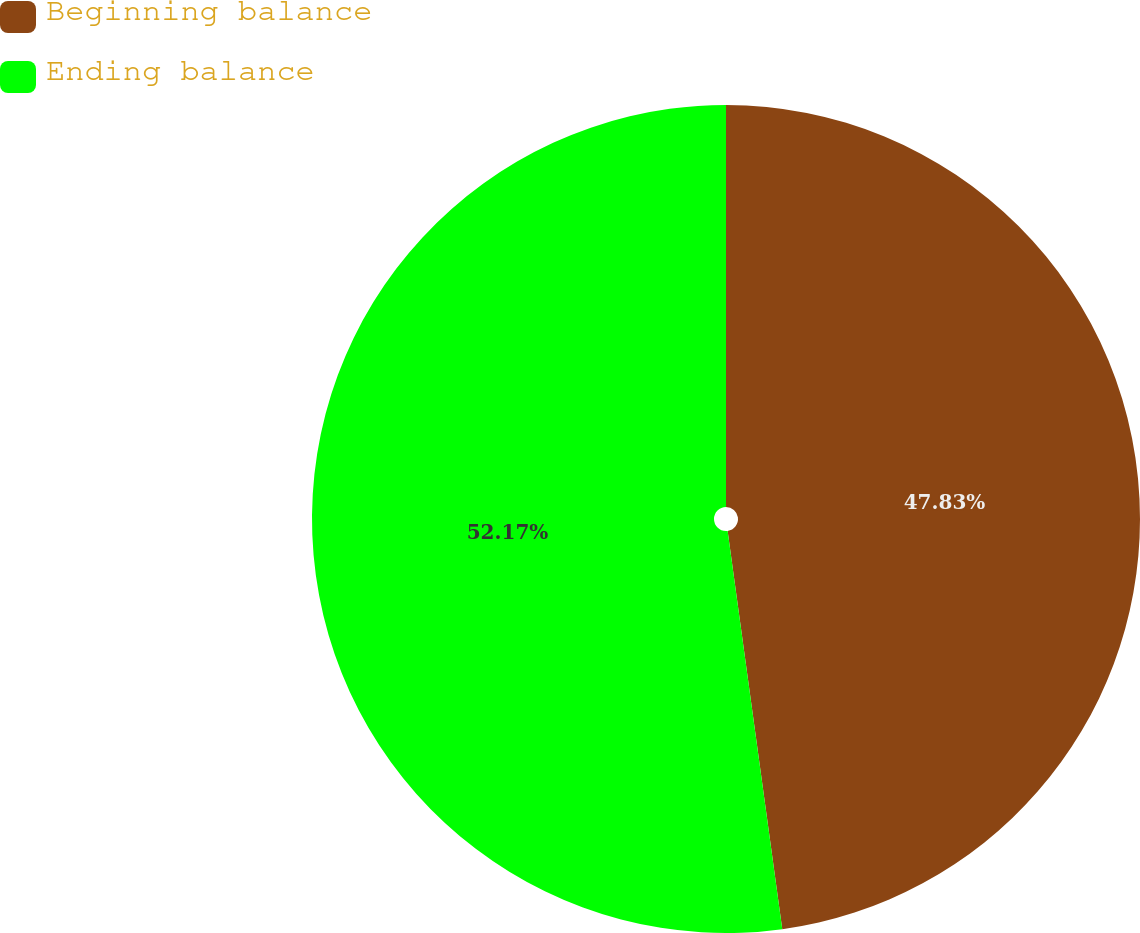Convert chart to OTSL. <chart><loc_0><loc_0><loc_500><loc_500><pie_chart><fcel>Beginning balance<fcel>Ending balance<nl><fcel>47.83%<fcel>52.17%<nl></chart> 